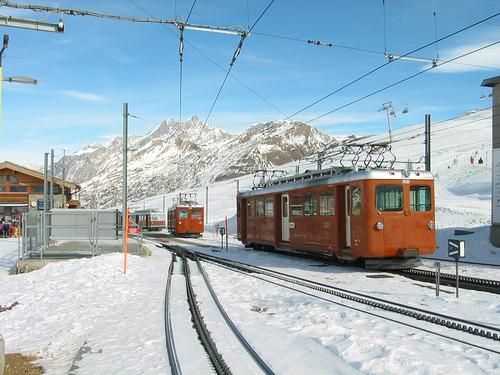What is ropeway called? train 